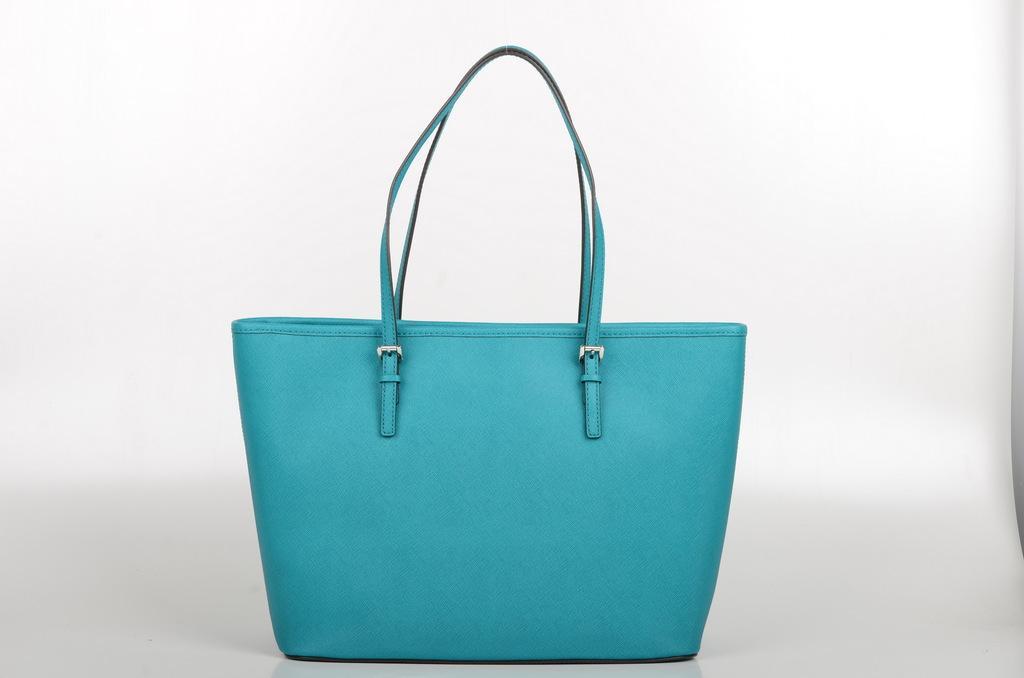Describe this image in one or two sentences. Here, we see blue color hand bag on a table like. This hand bag consists of two hangers which is fitted to it like a belt. It is a leather bag. On background, we find a white color thing like. 